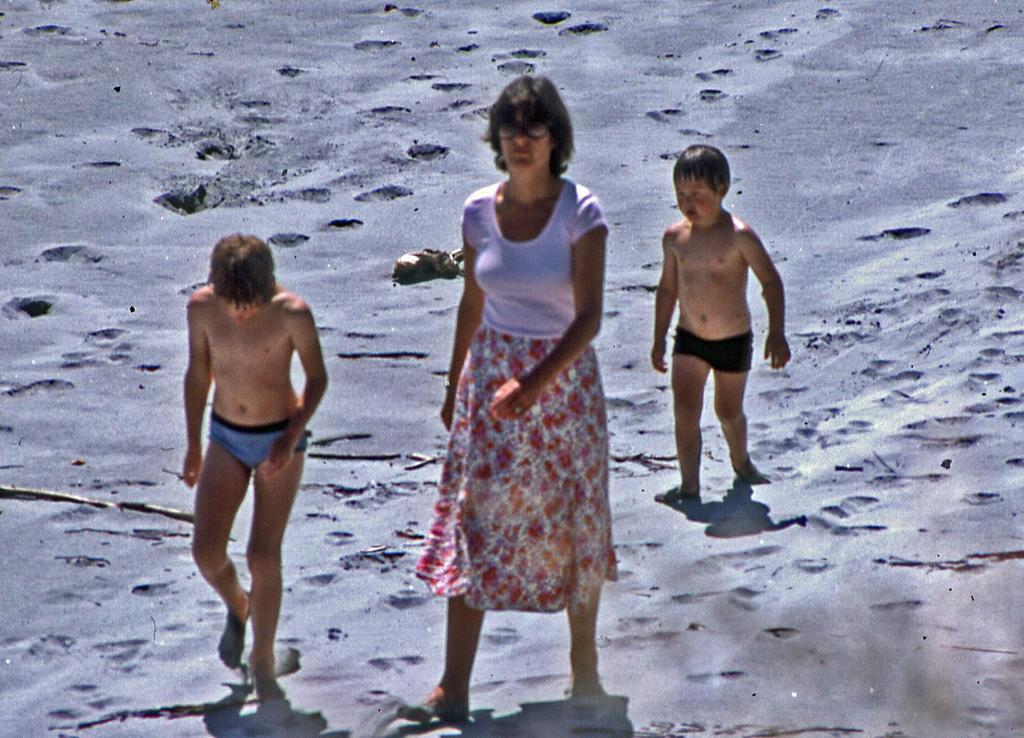How many people are in the image? There are three people in the image. Can you describe the gender of one of the people? One of the people is a woman. What is the age group of the other two people? The other two people are kids. What type of surface are the three people walking on? The three people are walking on the sand. What type of kettle can be seen boiling water in the image? There is no kettle present in the image. Is there a camp set up in the image? There is no camp set up in the image. Can you hear any thunder in the image? There is no sound or indication of thunder in the image. 